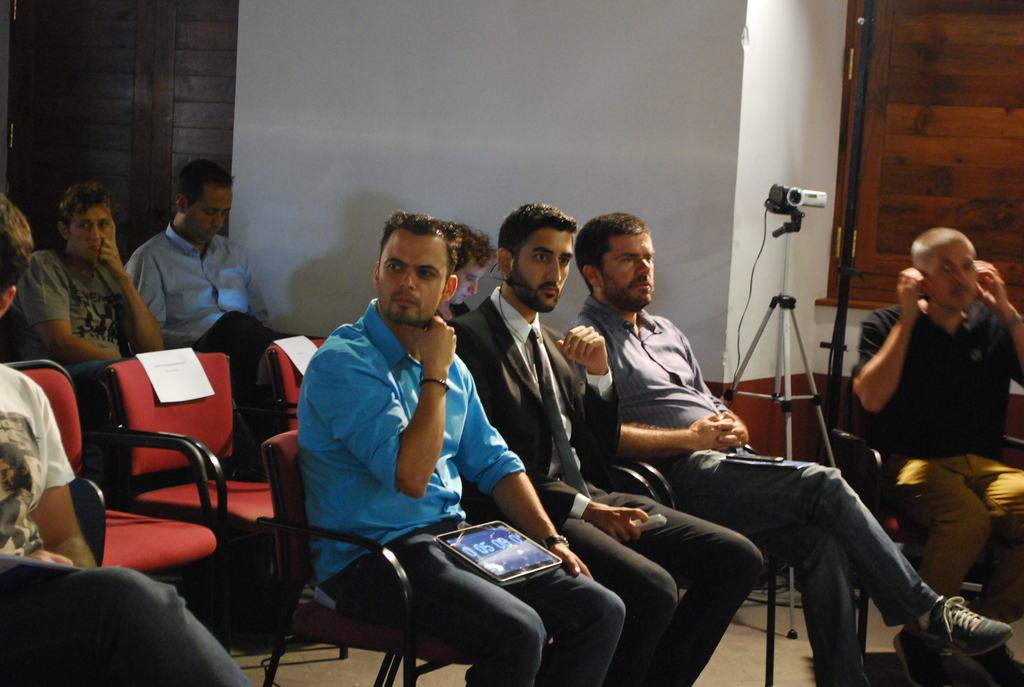What is happening in the image involving a group of people? There is a group of people in the image, and they are sitting on chairs. Can you describe any specific actions or objects held by the people? Yes, there is a person holding a tablet in their lap. What can be seen in the background of the image? There is a wall and a camera in the background of the image. What type of insect can be seen flying around the group of people in the image? There is no insect present in the image; it only shows a group of people sitting on chairs, one of whom is holding a tablet, with a wall and a camera in the background. 